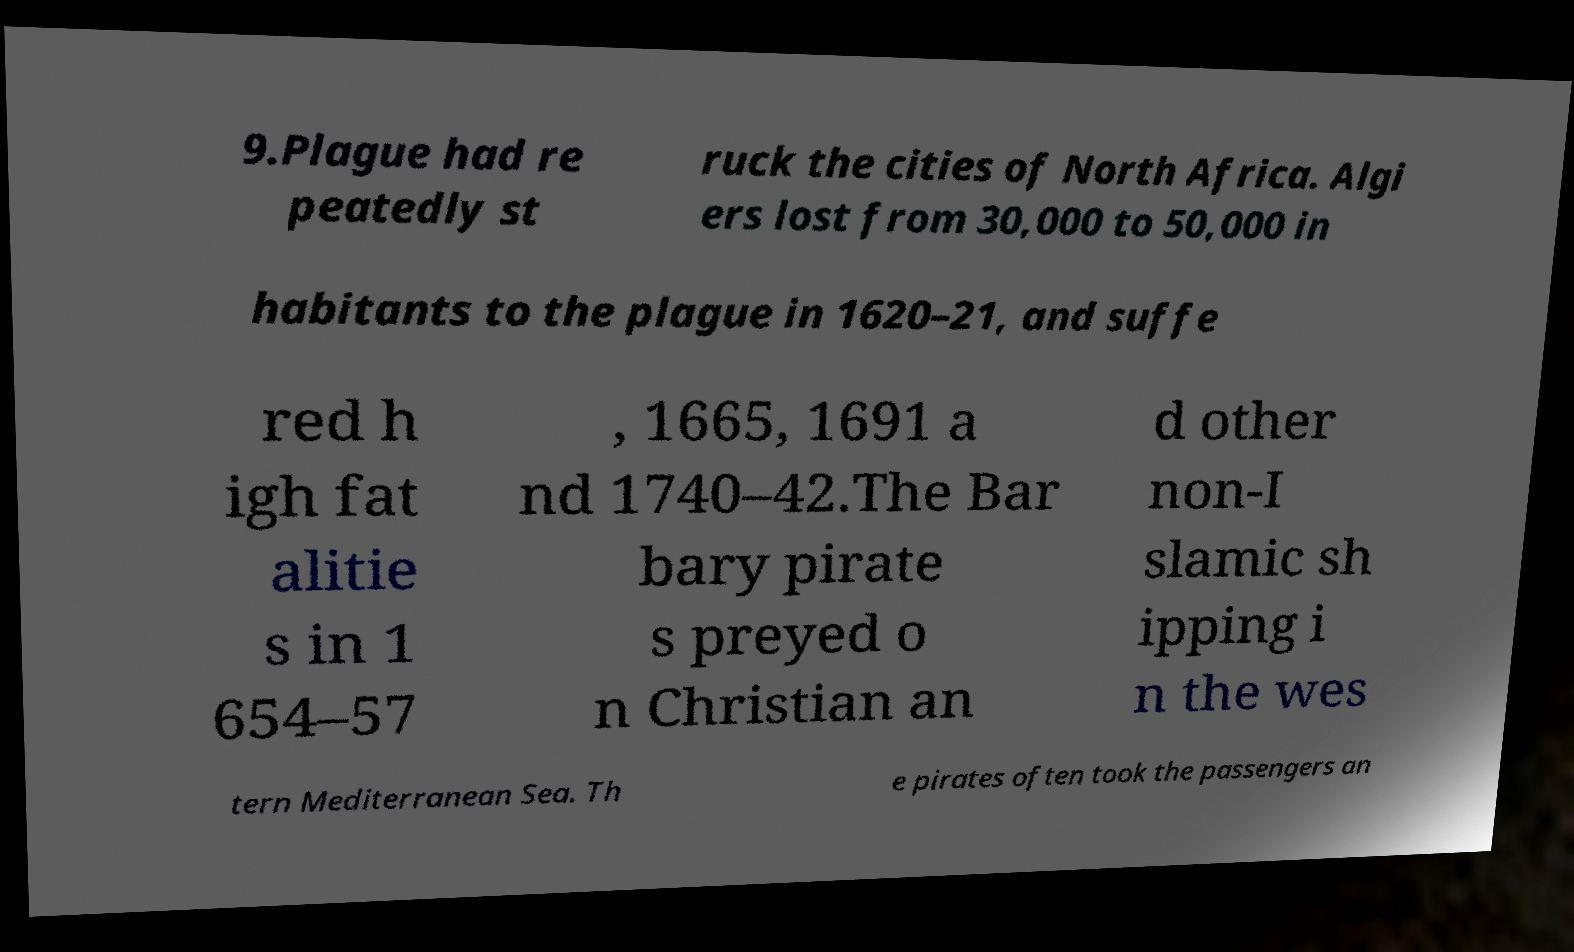There's text embedded in this image that I need extracted. Can you transcribe it verbatim? 9.Plague had re peatedly st ruck the cities of North Africa. Algi ers lost from 30,000 to 50,000 in habitants to the plague in 1620–21, and suffe red h igh fat alitie s in 1 654–57 , 1665, 1691 a nd 1740–42.The Bar bary pirate s preyed o n Christian an d other non-I slamic sh ipping i n the wes tern Mediterranean Sea. Th e pirates often took the passengers an 